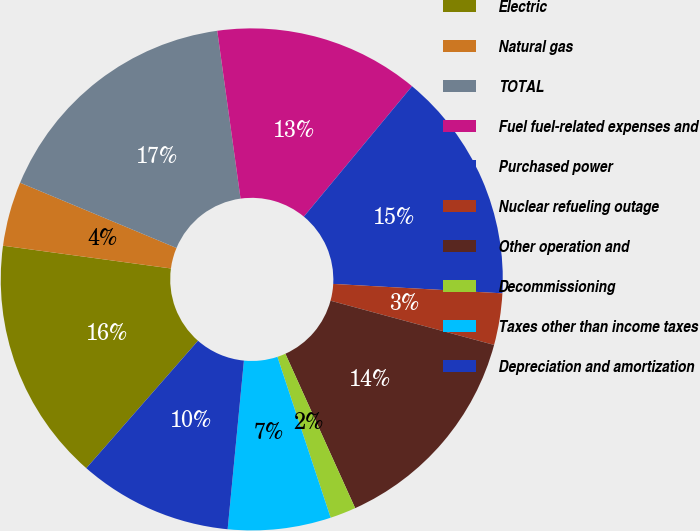Convert chart. <chart><loc_0><loc_0><loc_500><loc_500><pie_chart><fcel>Electric<fcel>Natural gas<fcel>TOTAL<fcel>Fuel fuel-related expenses and<fcel>Purchased power<fcel>Nuclear refueling outage<fcel>Other operation and<fcel>Decommissioning<fcel>Taxes other than income taxes<fcel>Depreciation and amortization<nl><fcel>15.69%<fcel>4.15%<fcel>16.51%<fcel>13.22%<fcel>14.86%<fcel>3.32%<fcel>14.04%<fcel>1.67%<fcel>6.62%<fcel>9.92%<nl></chart> 